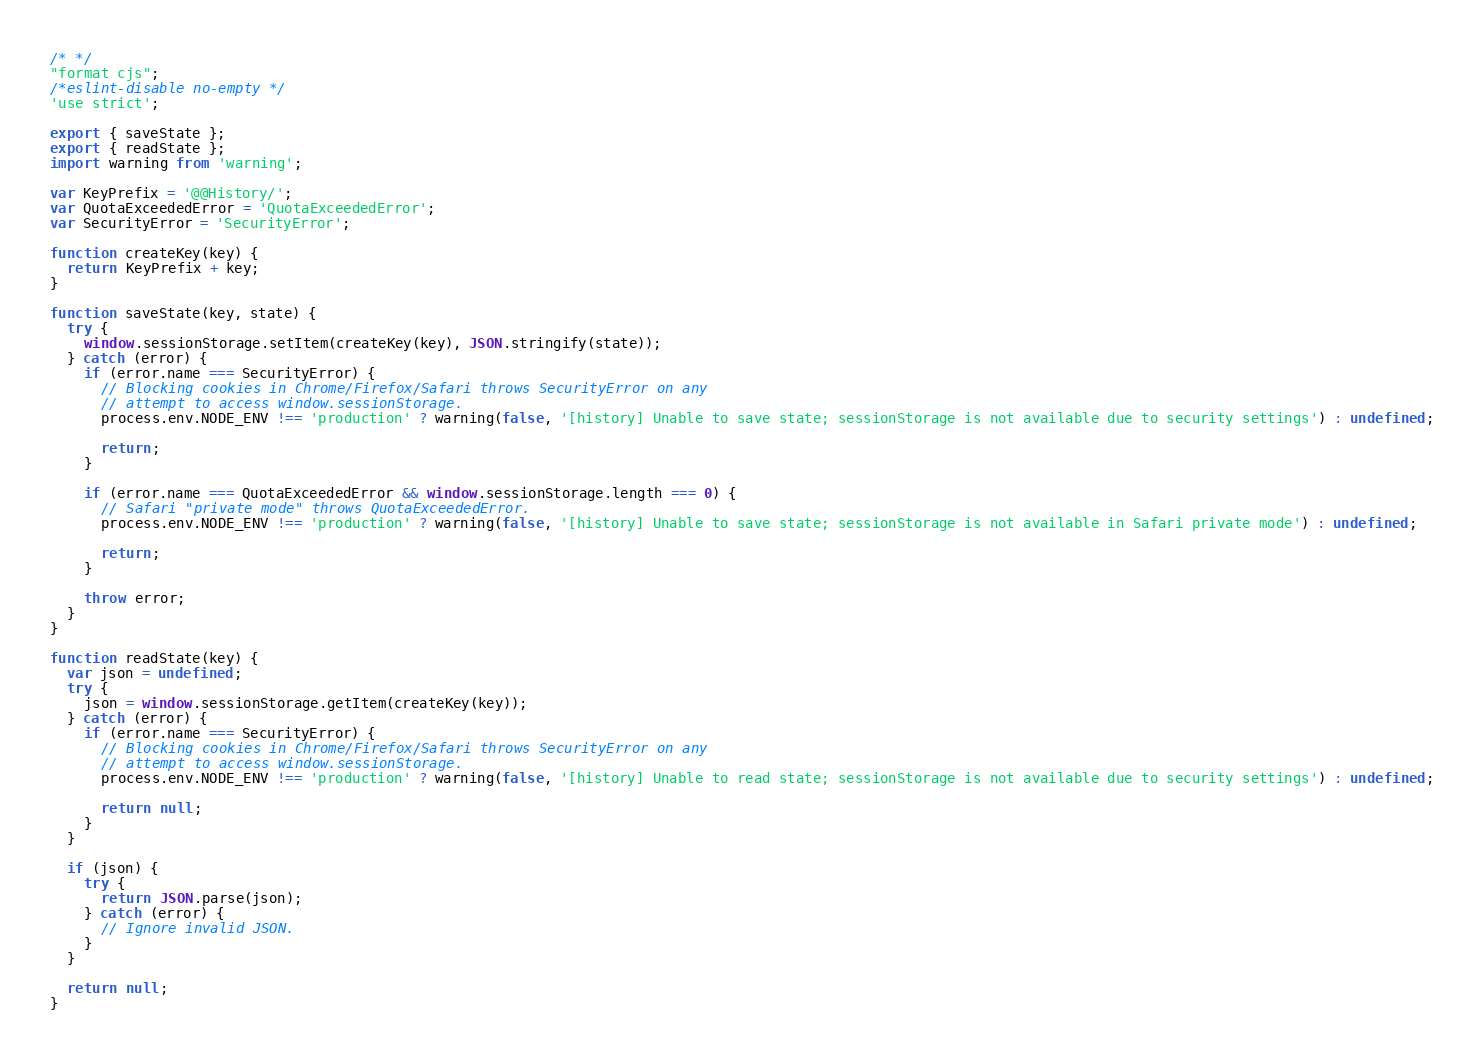<code> <loc_0><loc_0><loc_500><loc_500><_JavaScript_>/* */ 
"format cjs";
/*eslint-disable no-empty */
'use strict';

export { saveState };
export { readState };
import warning from 'warning';

var KeyPrefix = '@@History/';
var QuotaExceededError = 'QuotaExceededError';
var SecurityError = 'SecurityError';

function createKey(key) {
  return KeyPrefix + key;
}

function saveState(key, state) {
  try {
    window.sessionStorage.setItem(createKey(key), JSON.stringify(state));
  } catch (error) {
    if (error.name === SecurityError) {
      // Blocking cookies in Chrome/Firefox/Safari throws SecurityError on any
      // attempt to access window.sessionStorage.
      process.env.NODE_ENV !== 'production' ? warning(false, '[history] Unable to save state; sessionStorage is not available due to security settings') : undefined;

      return;
    }

    if (error.name === QuotaExceededError && window.sessionStorage.length === 0) {
      // Safari "private mode" throws QuotaExceededError.
      process.env.NODE_ENV !== 'production' ? warning(false, '[history] Unable to save state; sessionStorage is not available in Safari private mode') : undefined;

      return;
    }

    throw error;
  }
}

function readState(key) {
  var json = undefined;
  try {
    json = window.sessionStorage.getItem(createKey(key));
  } catch (error) {
    if (error.name === SecurityError) {
      // Blocking cookies in Chrome/Firefox/Safari throws SecurityError on any
      // attempt to access window.sessionStorage.
      process.env.NODE_ENV !== 'production' ? warning(false, '[history] Unable to read state; sessionStorage is not available due to security settings') : undefined;

      return null;
    }
  }

  if (json) {
    try {
      return JSON.parse(json);
    } catch (error) {
      // Ignore invalid JSON.
    }
  }

  return null;
}</code> 